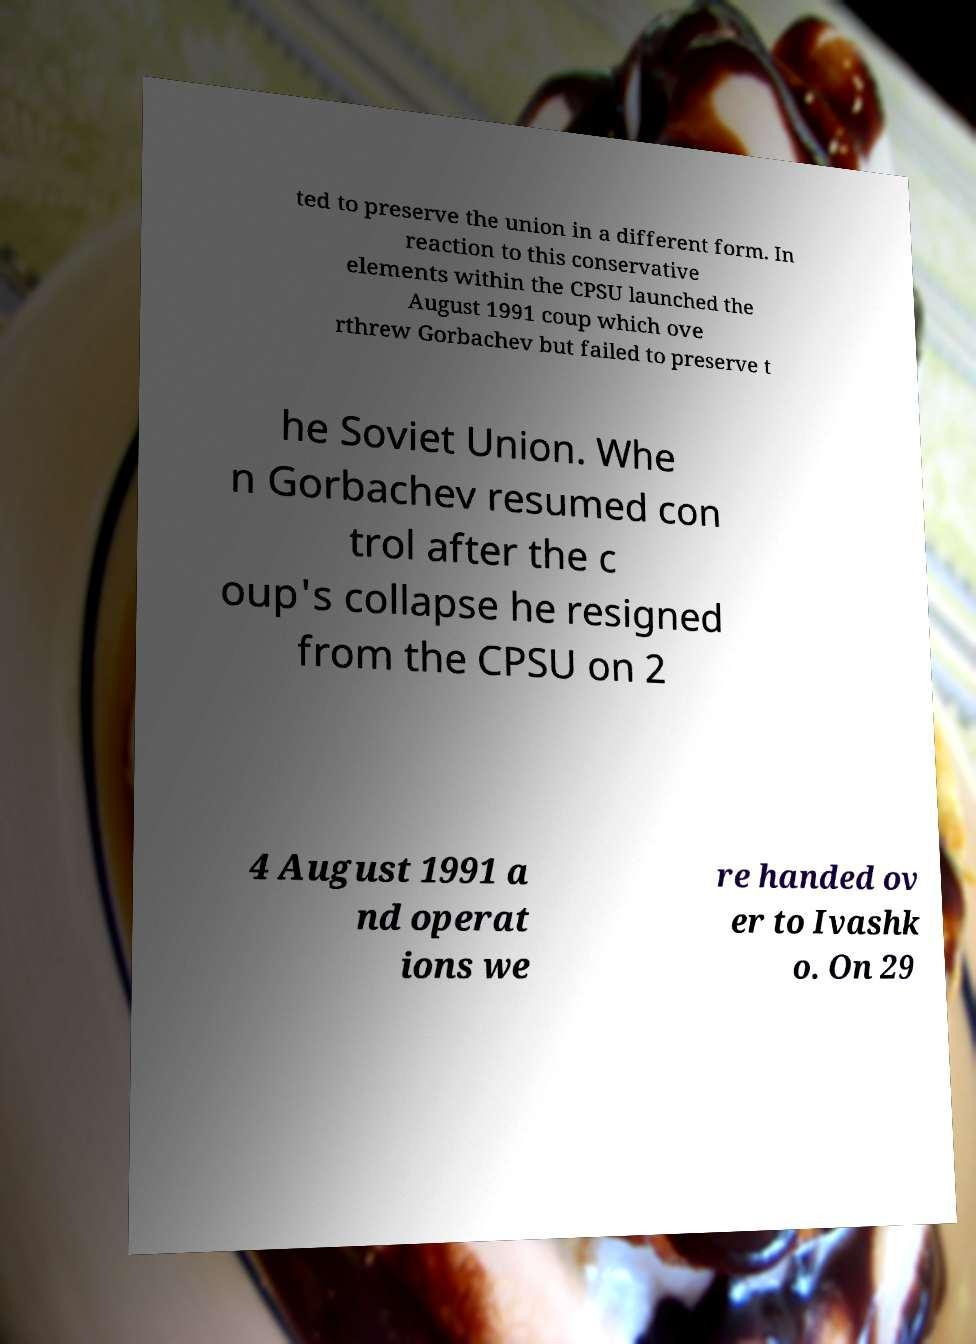Could you assist in decoding the text presented in this image and type it out clearly? ted to preserve the union in a different form. In reaction to this conservative elements within the CPSU launched the August 1991 coup which ove rthrew Gorbachev but failed to preserve t he Soviet Union. Whe n Gorbachev resumed con trol after the c oup's collapse he resigned from the CPSU on 2 4 August 1991 a nd operat ions we re handed ov er to Ivashk o. On 29 